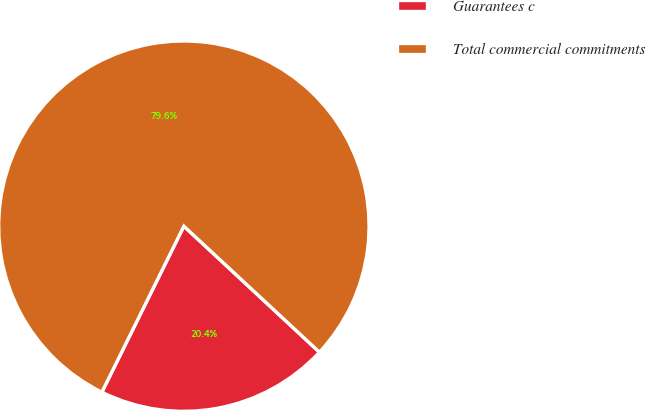Convert chart. <chart><loc_0><loc_0><loc_500><loc_500><pie_chart><fcel>Guarantees c<fcel>Total commercial commitments<nl><fcel>20.38%<fcel>79.62%<nl></chart> 